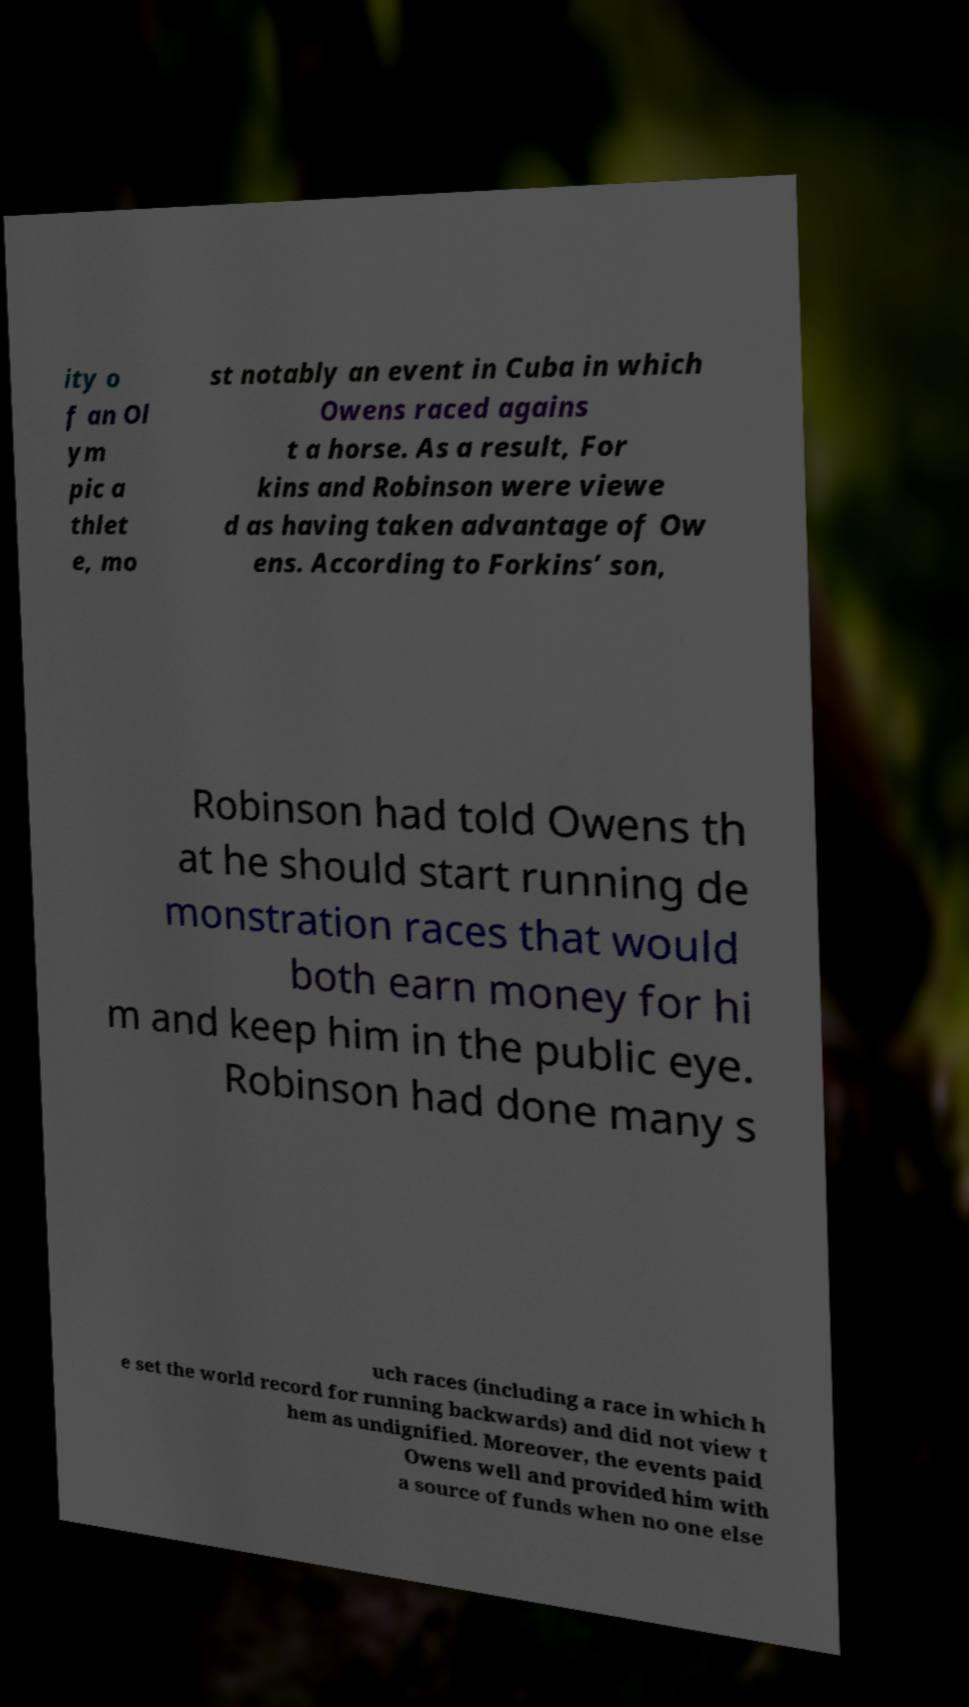Please identify and transcribe the text found in this image. ity o f an Ol ym pic a thlet e, mo st notably an event in Cuba in which Owens raced agains t a horse. As a result, For kins and Robinson were viewe d as having taken advantage of Ow ens. According to Forkins’ son, Robinson had told Owens th at he should start running de monstration races that would both earn money for hi m and keep him in the public eye. Robinson had done many s uch races (including a race in which h e set the world record for running backwards) and did not view t hem as undignified. Moreover, the events paid Owens well and provided him with a source of funds when no one else 